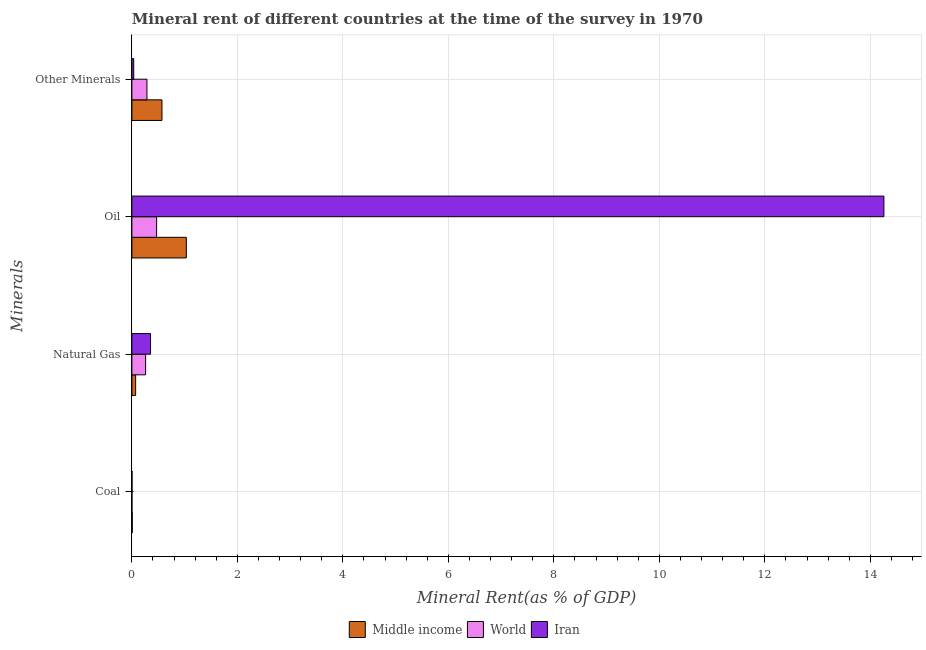How many groups of bars are there?
Provide a succinct answer. 4. How many bars are there on the 2nd tick from the top?
Ensure brevity in your answer.  3. How many bars are there on the 1st tick from the bottom?
Provide a succinct answer. 3. What is the label of the 4th group of bars from the top?
Give a very brief answer. Coal. What is the oil rent in World?
Offer a very short reply. 0.47. Across all countries, what is the maximum  rent of other minerals?
Ensure brevity in your answer.  0.57. Across all countries, what is the minimum natural gas rent?
Your response must be concise. 0.07. What is the total oil rent in the graph?
Give a very brief answer. 15.76. What is the difference between the  rent of other minerals in Iran and that in Middle income?
Your response must be concise. -0.54. What is the difference between the  rent of other minerals in World and the coal rent in Middle income?
Offer a terse response. 0.28. What is the average coal rent per country?
Offer a terse response. 0. What is the difference between the coal rent and  rent of other minerals in World?
Provide a short and direct response. -0.28. In how many countries, is the natural gas rent greater than 6 %?
Your response must be concise. 0. What is the ratio of the oil rent in Iran to that in World?
Offer a very short reply. 30.39. Is the difference between the  rent of other minerals in Middle income and World greater than the difference between the coal rent in Middle income and World?
Ensure brevity in your answer.  Yes. What is the difference between the highest and the second highest  rent of other minerals?
Keep it short and to the point. 0.28. What is the difference between the highest and the lowest  rent of other minerals?
Your answer should be very brief. 0.54. In how many countries, is the natural gas rent greater than the average natural gas rent taken over all countries?
Keep it short and to the point. 2. Is the sum of the coal rent in Iran and World greater than the maximum natural gas rent across all countries?
Provide a short and direct response. No. What does the 3rd bar from the bottom in Oil represents?
Ensure brevity in your answer.  Iran. How many bars are there?
Your response must be concise. 12. Are all the bars in the graph horizontal?
Your answer should be very brief. Yes. What is the difference between two consecutive major ticks on the X-axis?
Your response must be concise. 2. Are the values on the major ticks of X-axis written in scientific E-notation?
Your answer should be very brief. No. Does the graph contain any zero values?
Offer a very short reply. No. How many legend labels are there?
Your answer should be compact. 3. What is the title of the graph?
Offer a very short reply. Mineral rent of different countries at the time of the survey in 1970. Does "Bangladesh" appear as one of the legend labels in the graph?
Provide a succinct answer. No. What is the label or title of the X-axis?
Give a very brief answer. Mineral Rent(as % of GDP). What is the label or title of the Y-axis?
Provide a short and direct response. Minerals. What is the Mineral Rent(as % of GDP) of Middle income in Coal?
Provide a succinct answer. 0.01. What is the Mineral Rent(as % of GDP) of World in Coal?
Your response must be concise. 0. What is the Mineral Rent(as % of GDP) in Iran in Coal?
Provide a short and direct response. 0. What is the Mineral Rent(as % of GDP) in Middle income in Natural Gas?
Your response must be concise. 0.07. What is the Mineral Rent(as % of GDP) in World in Natural Gas?
Keep it short and to the point. 0.26. What is the Mineral Rent(as % of GDP) of Iran in Natural Gas?
Provide a short and direct response. 0.35. What is the Mineral Rent(as % of GDP) in Middle income in Oil?
Your answer should be very brief. 1.03. What is the Mineral Rent(as % of GDP) of World in Oil?
Make the answer very short. 0.47. What is the Mineral Rent(as % of GDP) in Iran in Oil?
Offer a terse response. 14.26. What is the Mineral Rent(as % of GDP) of Middle income in Other Minerals?
Keep it short and to the point. 0.57. What is the Mineral Rent(as % of GDP) of World in Other Minerals?
Your answer should be very brief. 0.29. What is the Mineral Rent(as % of GDP) in Iran in Other Minerals?
Give a very brief answer. 0.04. Across all Minerals, what is the maximum Mineral Rent(as % of GDP) in Middle income?
Your answer should be very brief. 1.03. Across all Minerals, what is the maximum Mineral Rent(as % of GDP) in World?
Give a very brief answer. 0.47. Across all Minerals, what is the maximum Mineral Rent(as % of GDP) in Iran?
Provide a succinct answer. 14.26. Across all Minerals, what is the minimum Mineral Rent(as % of GDP) of Middle income?
Ensure brevity in your answer.  0.01. Across all Minerals, what is the minimum Mineral Rent(as % of GDP) of World?
Ensure brevity in your answer.  0. Across all Minerals, what is the minimum Mineral Rent(as % of GDP) of Iran?
Your answer should be compact. 0. What is the total Mineral Rent(as % of GDP) in Middle income in the graph?
Offer a very short reply. 1.68. What is the total Mineral Rent(as % of GDP) of World in the graph?
Make the answer very short. 1.02. What is the total Mineral Rent(as % of GDP) in Iran in the graph?
Make the answer very short. 14.65. What is the difference between the Mineral Rent(as % of GDP) in Middle income in Coal and that in Natural Gas?
Ensure brevity in your answer.  -0.06. What is the difference between the Mineral Rent(as % of GDP) in World in Coal and that in Natural Gas?
Make the answer very short. -0.26. What is the difference between the Mineral Rent(as % of GDP) in Iran in Coal and that in Natural Gas?
Offer a very short reply. -0.35. What is the difference between the Mineral Rent(as % of GDP) of Middle income in Coal and that in Oil?
Your answer should be compact. -1.02. What is the difference between the Mineral Rent(as % of GDP) of World in Coal and that in Oil?
Your answer should be very brief. -0.47. What is the difference between the Mineral Rent(as % of GDP) in Iran in Coal and that in Oil?
Your response must be concise. -14.25. What is the difference between the Mineral Rent(as % of GDP) in Middle income in Coal and that in Other Minerals?
Provide a short and direct response. -0.56. What is the difference between the Mineral Rent(as % of GDP) of World in Coal and that in Other Minerals?
Make the answer very short. -0.28. What is the difference between the Mineral Rent(as % of GDP) of Iran in Coal and that in Other Minerals?
Give a very brief answer. -0.03. What is the difference between the Mineral Rent(as % of GDP) of Middle income in Natural Gas and that in Oil?
Provide a succinct answer. -0.96. What is the difference between the Mineral Rent(as % of GDP) of World in Natural Gas and that in Oil?
Your answer should be compact. -0.21. What is the difference between the Mineral Rent(as % of GDP) in Iran in Natural Gas and that in Oil?
Offer a terse response. -13.9. What is the difference between the Mineral Rent(as % of GDP) of Middle income in Natural Gas and that in Other Minerals?
Your answer should be compact. -0.5. What is the difference between the Mineral Rent(as % of GDP) in World in Natural Gas and that in Other Minerals?
Offer a terse response. -0.03. What is the difference between the Mineral Rent(as % of GDP) of Iran in Natural Gas and that in Other Minerals?
Your answer should be very brief. 0.32. What is the difference between the Mineral Rent(as % of GDP) of Middle income in Oil and that in Other Minerals?
Your response must be concise. 0.46. What is the difference between the Mineral Rent(as % of GDP) in World in Oil and that in Other Minerals?
Ensure brevity in your answer.  0.18. What is the difference between the Mineral Rent(as % of GDP) in Iran in Oil and that in Other Minerals?
Give a very brief answer. 14.22. What is the difference between the Mineral Rent(as % of GDP) of Middle income in Coal and the Mineral Rent(as % of GDP) of World in Natural Gas?
Your answer should be compact. -0.25. What is the difference between the Mineral Rent(as % of GDP) in Middle income in Coal and the Mineral Rent(as % of GDP) in Iran in Natural Gas?
Your response must be concise. -0.35. What is the difference between the Mineral Rent(as % of GDP) of World in Coal and the Mineral Rent(as % of GDP) of Iran in Natural Gas?
Provide a short and direct response. -0.35. What is the difference between the Mineral Rent(as % of GDP) of Middle income in Coal and the Mineral Rent(as % of GDP) of World in Oil?
Make the answer very short. -0.46. What is the difference between the Mineral Rent(as % of GDP) in Middle income in Coal and the Mineral Rent(as % of GDP) in Iran in Oil?
Give a very brief answer. -14.25. What is the difference between the Mineral Rent(as % of GDP) of World in Coal and the Mineral Rent(as % of GDP) of Iran in Oil?
Keep it short and to the point. -14.26. What is the difference between the Mineral Rent(as % of GDP) in Middle income in Coal and the Mineral Rent(as % of GDP) in World in Other Minerals?
Provide a short and direct response. -0.28. What is the difference between the Mineral Rent(as % of GDP) in Middle income in Coal and the Mineral Rent(as % of GDP) in Iran in Other Minerals?
Your answer should be compact. -0.03. What is the difference between the Mineral Rent(as % of GDP) of World in Coal and the Mineral Rent(as % of GDP) of Iran in Other Minerals?
Offer a very short reply. -0.03. What is the difference between the Mineral Rent(as % of GDP) in Middle income in Natural Gas and the Mineral Rent(as % of GDP) in World in Oil?
Ensure brevity in your answer.  -0.4. What is the difference between the Mineral Rent(as % of GDP) in Middle income in Natural Gas and the Mineral Rent(as % of GDP) in Iran in Oil?
Give a very brief answer. -14.19. What is the difference between the Mineral Rent(as % of GDP) in World in Natural Gas and the Mineral Rent(as % of GDP) in Iran in Oil?
Give a very brief answer. -14. What is the difference between the Mineral Rent(as % of GDP) of Middle income in Natural Gas and the Mineral Rent(as % of GDP) of World in Other Minerals?
Make the answer very short. -0.21. What is the difference between the Mineral Rent(as % of GDP) in Middle income in Natural Gas and the Mineral Rent(as % of GDP) in Iran in Other Minerals?
Ensure brevity in your answer.  0.04. What is the difference between the Mineral Rent(as % of GDP) in World in Natural Gas and the Mineral Rent(as % of GDP) in Iran in Other Minerals?
Offer a terse response. 0.23. What is the difference between the Mineral Rent(as % of GDP) in Middle income in Oil and the Mineral Rent(as % of GDP) in World in Other Minerals?
Provide a succinct answer. 0.75. What is the difference between the Mineral Rent(as % of GDP) of World in Oil and the Mineral Rent(as % of GDP) of Iran in Other Minerals?
Offer a terse response. 0.43. What is the average Mineral Rent(as % of GDP) of Middle income per Minerals?
Your response must be concise. 0.42. What is the average Mineral Rent(as % of GDP) of World per Minerals?
Give a very brief answer. 0.25. What is the average Mineral Rent(as % of GDP) in Iran per Minerals?
Offer a very short reply. 3.66. What is the difference between the Mineral Rent(as % of GDP) in Middle income and Mineral Rent(as % of GDP) in World in Coal?
Keep it short and to the point. 0.01. What is the difference between the Mineral Rent(as % of GDP) of Middle income and Mineral Rent(as % of GDP) of Iran in Coal?
Offer a terse response. 0. What is the difference between the Mineral Rent(as % of GDP) of World and Mineral Rent(as % of GDP) of Iran in Coal?
Keep it short and to the point. -0. What is the difference between the Mineral Rent(as % of GDP) in Middle income and Mineral Rent(as % of GDP) in World in Natural Gas?
Your answer should be compact. -0.19. What is the difference between the Mineral Rent(as % of GDP) in Middle income and Mineral Rent(as % of GDP) in Iran in Natural Gas?
Give a very brief answer. -0.28. What is the difference between the Mineral Rent(as % of GDP) in World and Mineral Rent(as % of GDP) in Iran in Natural Gas?
Ensure brevity in your answer.  -0.09. What is the difference between the Mineral Rent(as % of GDP) in Middle income and Mineral Rent(as % of GDP) in World in Oil?
Offer a very short reply. 0.56. What is the difference between the Mineral Rent(as % of GDP) in Middle income and Mineral Rent(as % of GDP) in Iran in Oil?
Offer a very short reply. -13.23. What is the difference between the Mineral Rent(as % of GDP) in World and Mineral Rent(as % of GDP) in Iran in Oil?
Offer a very short reply. -13.79. What is the difference between the Mineral Rent(as % of GDP) of Middle income and Mineral Rent(as % of GDP) of World in Other Minerals?
Offer a terse response. 0.28. What is the difference between the Mineral Rent(as % of GDP) in Middle income and Mineral Rent(as % of GDP) in Iran in Other Minerals?
Give a very brief answer. 0.54. What is the difference between the Mineral Rent(as % of GDP) in World and Mineral Rent(as % of GDP) in Iran in Other Minerals?
Provide a short and direct response. 0.25. What is the ratio of the Mineral Rent(as % of GDP) in Middle income in Coal to that in Natural Gas?
Make the answer very short. 0.1. What is the ratio of the Mineral Rent(as % of GDP) in World in Coal to that in Natural Gas?
Provide a short and direct response. 0. What is the ratio of the Mineral Rent(as % of GDP) in Iran in Coal to that in Natural Gas?
Give a very brief answer. 0.01. What is the ratio of the Mineral Rent(as % of GDP) of Middle income in Coal to that in Oil?
Provide a short and direct response. 0.01. What is the ratio of the Mineral Rent(as % of GDP) in World in Coal to that in Oil?
Your response must be concise. 0. What is the ratio of the Mineral Rent(as % of GDP) in Iran in Coal to that in Oil?
Give a very brief answer. 0. What is the ratio of the Mineral Rent(as % of GDP) in Middle income in Coal to that in Other Minerals?
Your answer should be compact. 0.01. What is the ratio of the Mineral Rent(as % of GDP) of World in Coal to that in Other Minerals?
Offer a very short reply. 0. What is the ratio of the Mineral Rent(as % of GDP) in Iran in Coal to that in Other Minerals?
Offer a very short reply. 0.07. What is the ratio of the Mineral Rent(as % of GDP) in Middle income in Natural Gas to that in Oil?
Make the answer very short. 0.07. What is the ratio of the Mineral Rent(as % of GDP) in World in Natural Gas to that in Oil?
Offer a terse response. 0.56. What is the ratio of the Mineral Rent(as % of GDP) of Iran in Natural Gas to that in Oil?
Offer a very short reply. 0.02. What is the ratio of the Mineral Rent(as % of GDP) of Middle income in Natural Gas to that in Other Minerals?
Provide a succinct answer. 0.13. What is the ratio of the Mineral Rent(as % of GDP) in World in Natural Gas to that in Other Minerals?
Offer a very short reply. 0.91. What is the ratio of the Mineral Rent(as % of GDP) of Iran in Natural Gas to that in Other Minerals?
Make the answer very short. 10.09. What is the ratio of the Mineral Rent(as % of GDP) of Middle income in Oil to that in Other Minerals?
Give a very brief answer. 1.81. What is the ratio of the Mineral Rent(as % of GDP) in World in Oil to that in Other Minerals?
Offer a terse response. 1.64. What is the ratio of the Mineral Rent(as % of GDP) of Iran in Oil to that in Other Minerals?
Your answer should be very brief. 406.14. What is the difference between the highest and the second highest Mineral Rent(as % of GDP) in Middle income?
Your answer should be compact. 0.46. What is the difference between the highest and the second highest Mineral Rent(as % of GDP) in World?
Your answer should be very brief. 0.18. What is the difference between the highest and the second highest Mineral Rent(as % of GDP) in Iran?
Ensure brevity in your answer.  13.9. What is the difference between the highest and the lowest Mineral Rent(as % of GDP) in Middle income?
Keep it short and to the point. 1.02. What is the difference between the highest and the lowest Mineral Rent(as % of GDP) in World?
Provide a short and direct response. 0.47. What is the difference between the highest and the lowest Mineral Rent(as % of GDP) of Iran?
Your response must be concise. 14.25. 